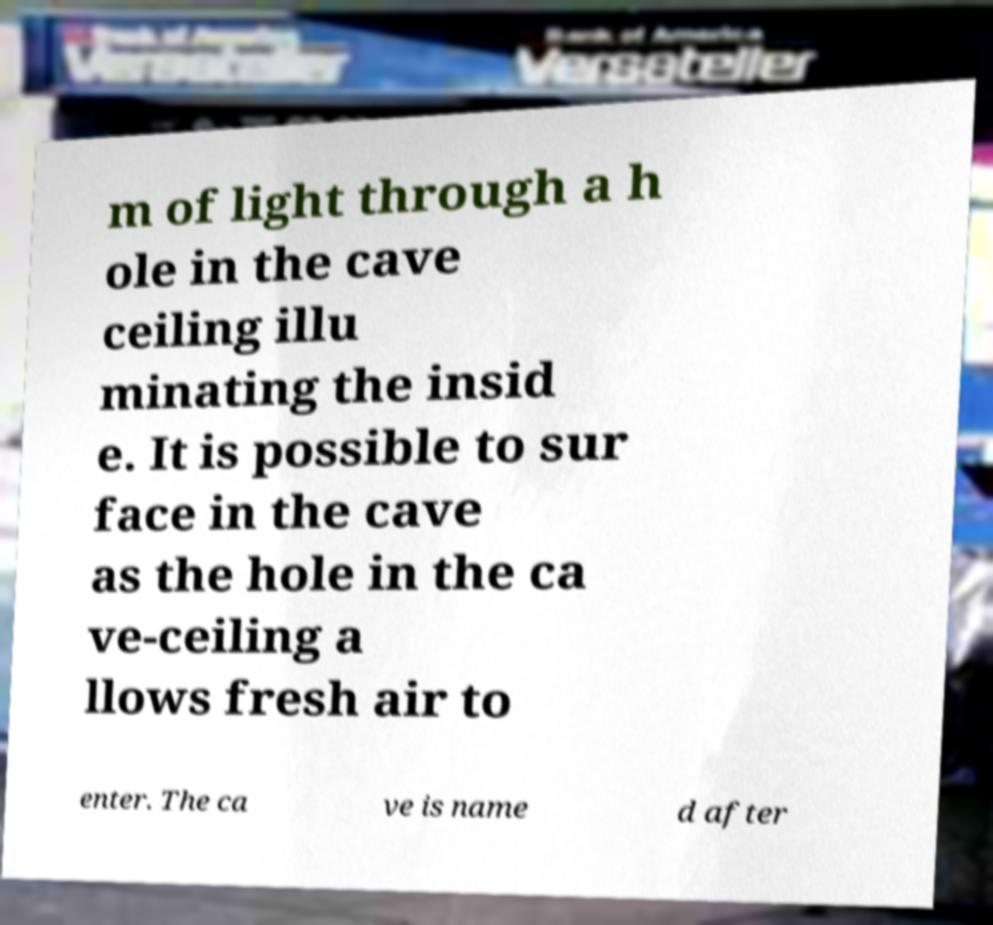I need the written content from this picture converted into text. Can you do that? m of light through a h ole in the cave ceiling illu minating the insid e. It is possible to sur face in the cave as the hole in the ca ve-ceiling a llows fresh air to enter. The ca ve is name d after 